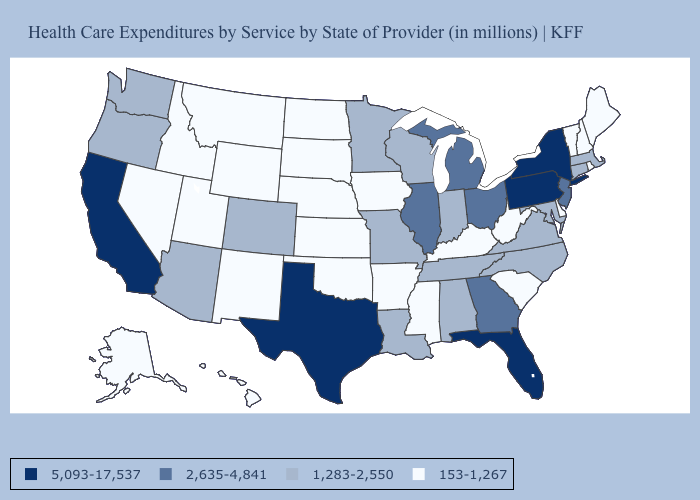Name the states that have a value in the range 2,635-4,841?
Give a very brief answer. Georgia, Illinois, Michigan, New Jersey, Ohio. What is the highest value in states that border New York?
Concise answer only. 5,093-17,537. Name the states that have a value in the range 153-1,267?
Quick response, please. Alaska, Arkansas, Delaware, Hawaii, Idaho, Iowa, Kansas, Kentucky, Maine, Mississippi, Montana, Nebraska, Nevada, New Hampshire, New Mexico, North Dakota, Oklahoma, Rhode Island, South Carolina, South Dakota, Utah, Vermont, West Virginia, Wyoming. Does Nevada have the highest value in the West?
Give a very brief answer. No. What is the highest value in the USA?
Concise answer only. 5,093-17,537. What is the value of North Carolina?
Short answer required. 1,283-2,550. Does Texas have the highest value in the USA?
Give a very brief answer. Yes. Which states have the highest value in the USA?
Keep it brief. California, Florida, New York, Pennsylvania, Texas. Name the states that have a value in the range 1,283-2,550?
Short answer required. Alabama, Arizona, Colorado, Connecticut, Indiana, Louisiana, Maryland, Massachusetts, Minnesota, Missouri, North Carolina, Oregon, Tennessee, Virginia, Washington, Wisconsin. Does Texas have the highest value in the South?
Write a very short answer. Yes. What is the value of Montana?
Be succinct. 153-1,267. Does the first symbol in the legend represent the smallest category?
Keep it brief. No. What is the value of Utah?
Be succinct. 153-1,267. What is the lowest value in states that border New Jersey?
Give a very brief answer. 153-1,267. 